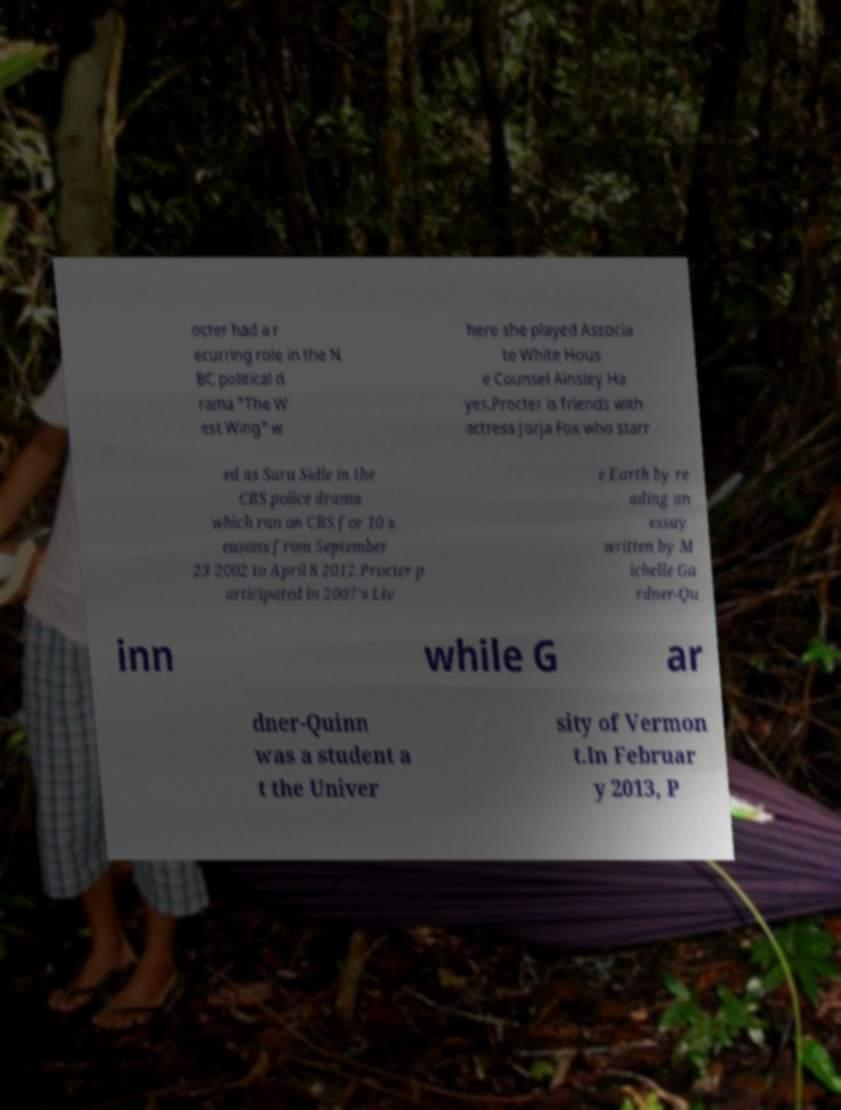Can you accurately transcribe the text from the provided image for me? octer had a r ecurring role in the N BC political d rama "The W est Wing" w here she played Associa te White Hous e Counsel Ainsley Ha yes.Procter is friends with actress Jorja Fox who starr ed as Sara Sidle in the CBS police drama which ran on CBS for 10 s easons from September 23 2002 to April 8 2012.Procter p articipated in 2007's Liv e Earth by re ading an essay written by M ichelle Ga rdner-Qu inn while G ar dner-Quinn was a student a t the Univer sity of Vermon t.In Februar y 2013, P 